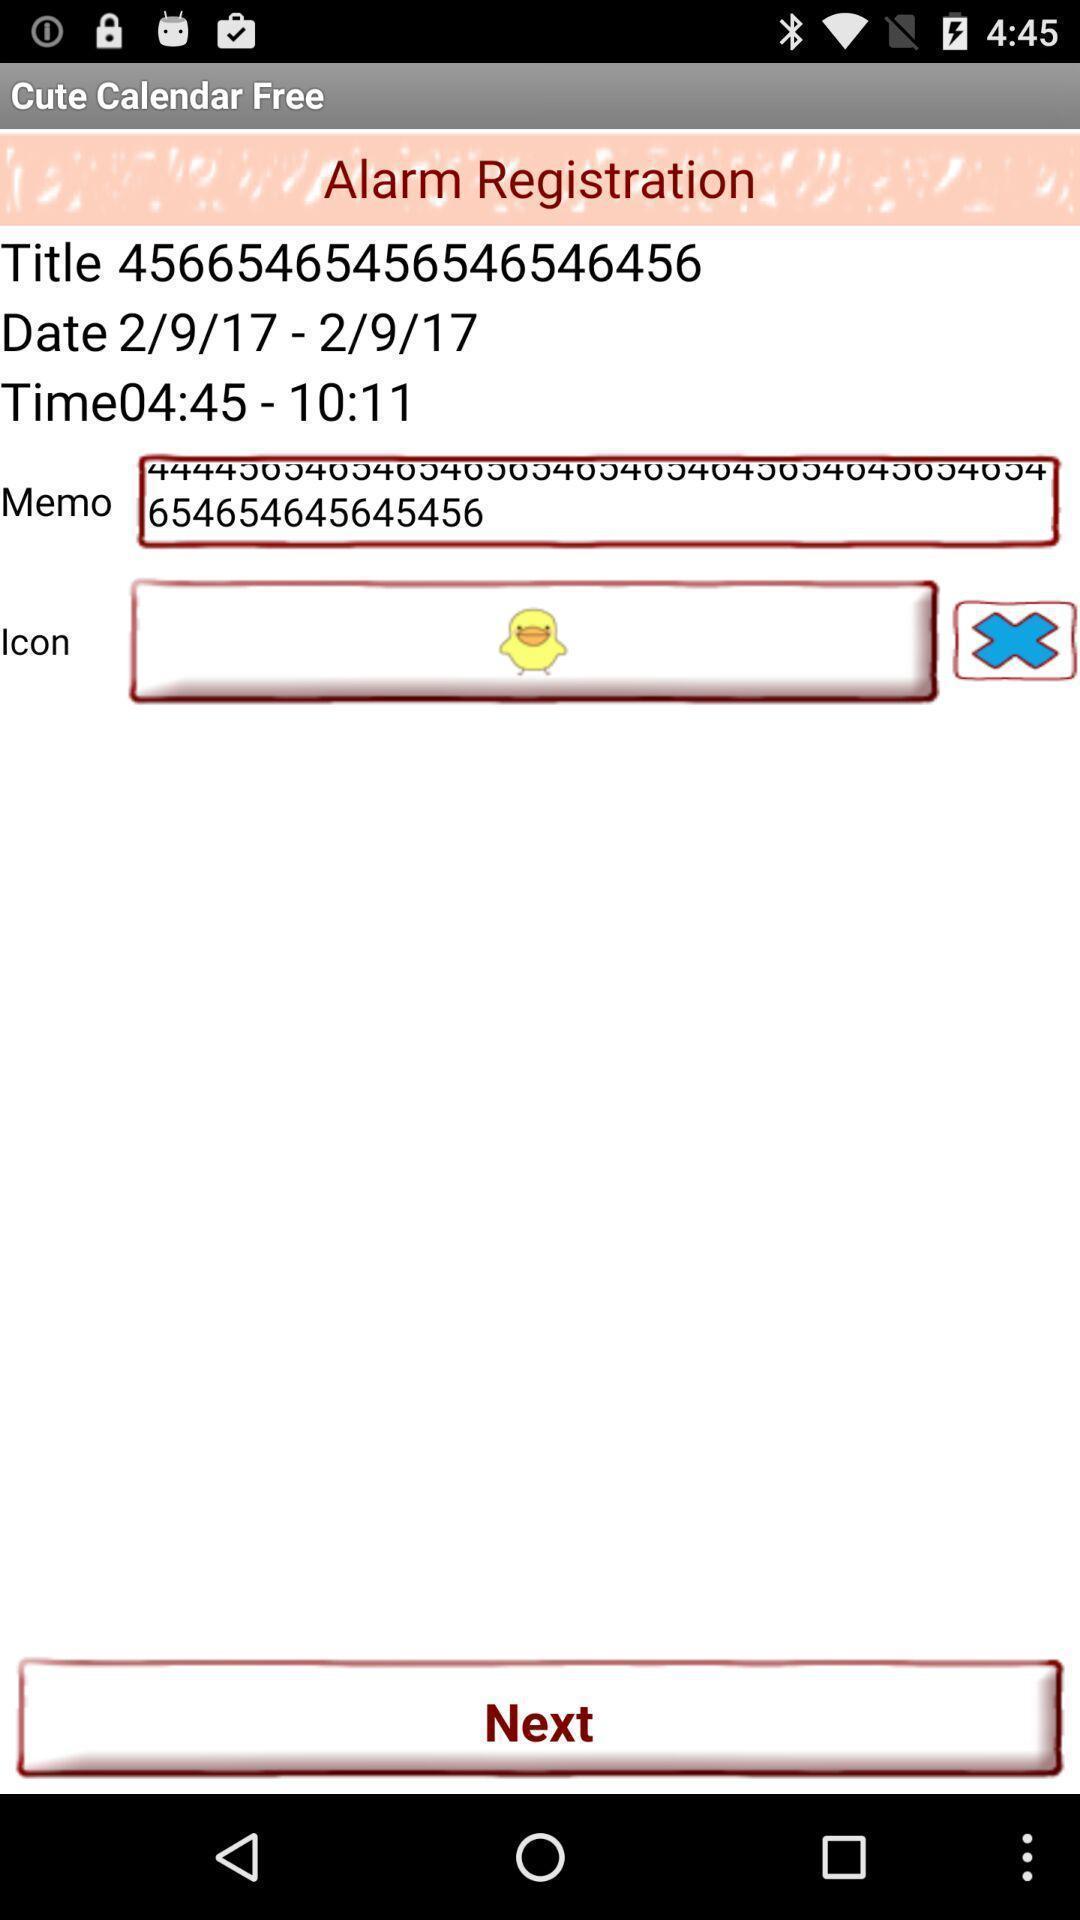Describe the visual elements of this screenshot. Screen shows an alarm registration. 